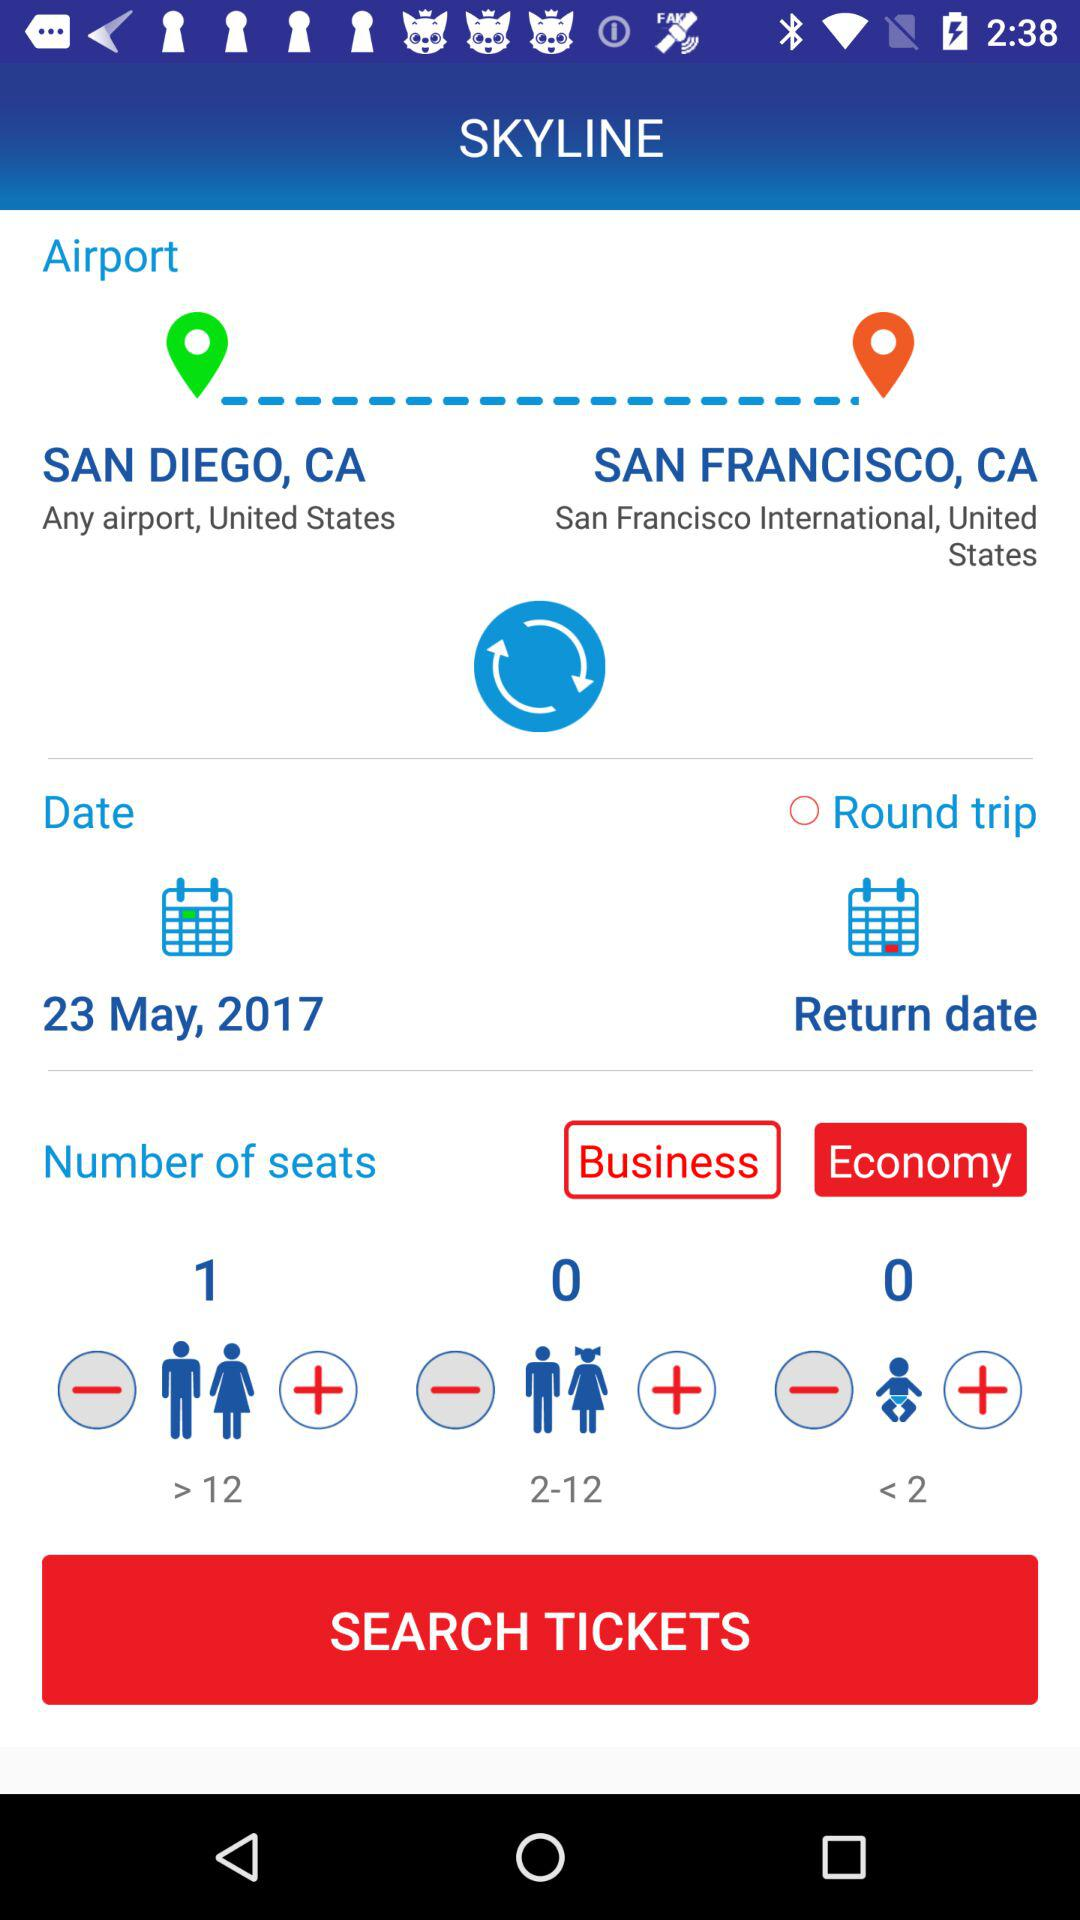Which is the destination location? The destination location is San Francisco, CA. 